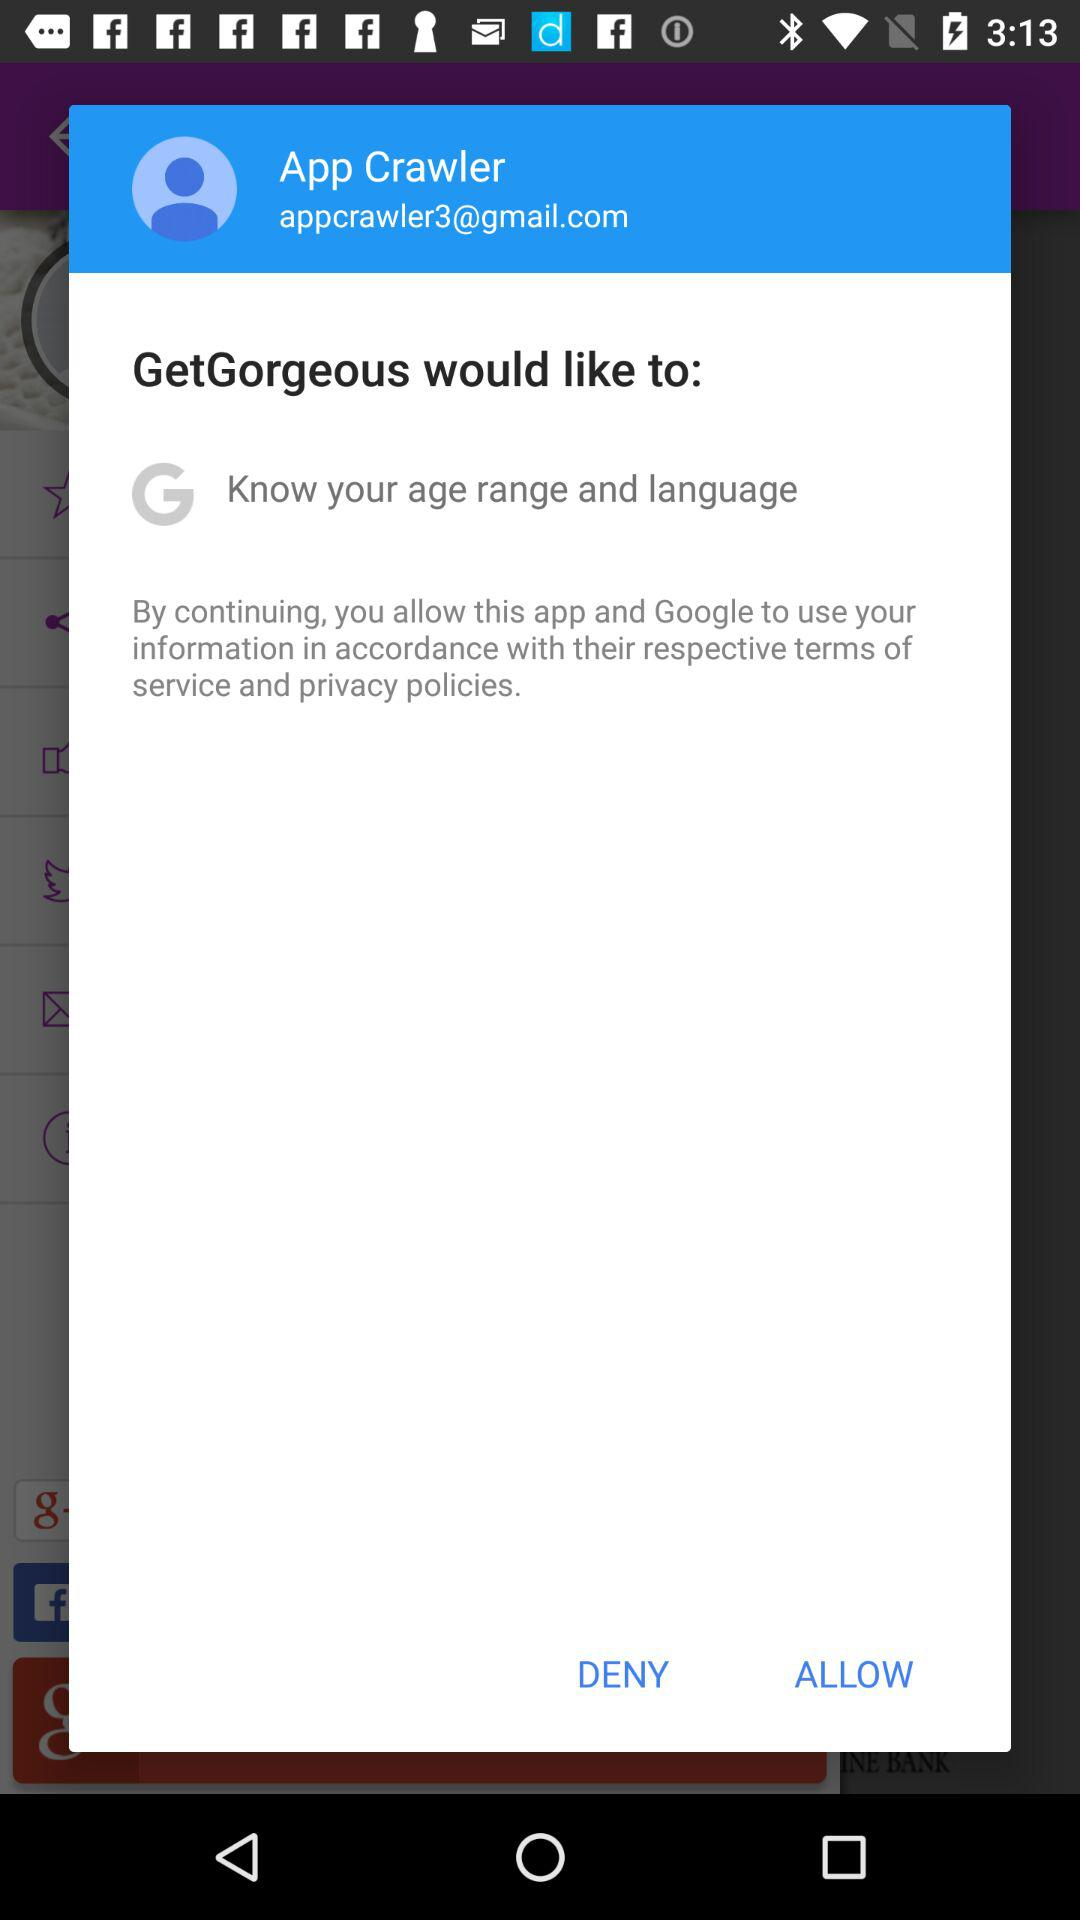What is the user name? The user name is App Crawler. 